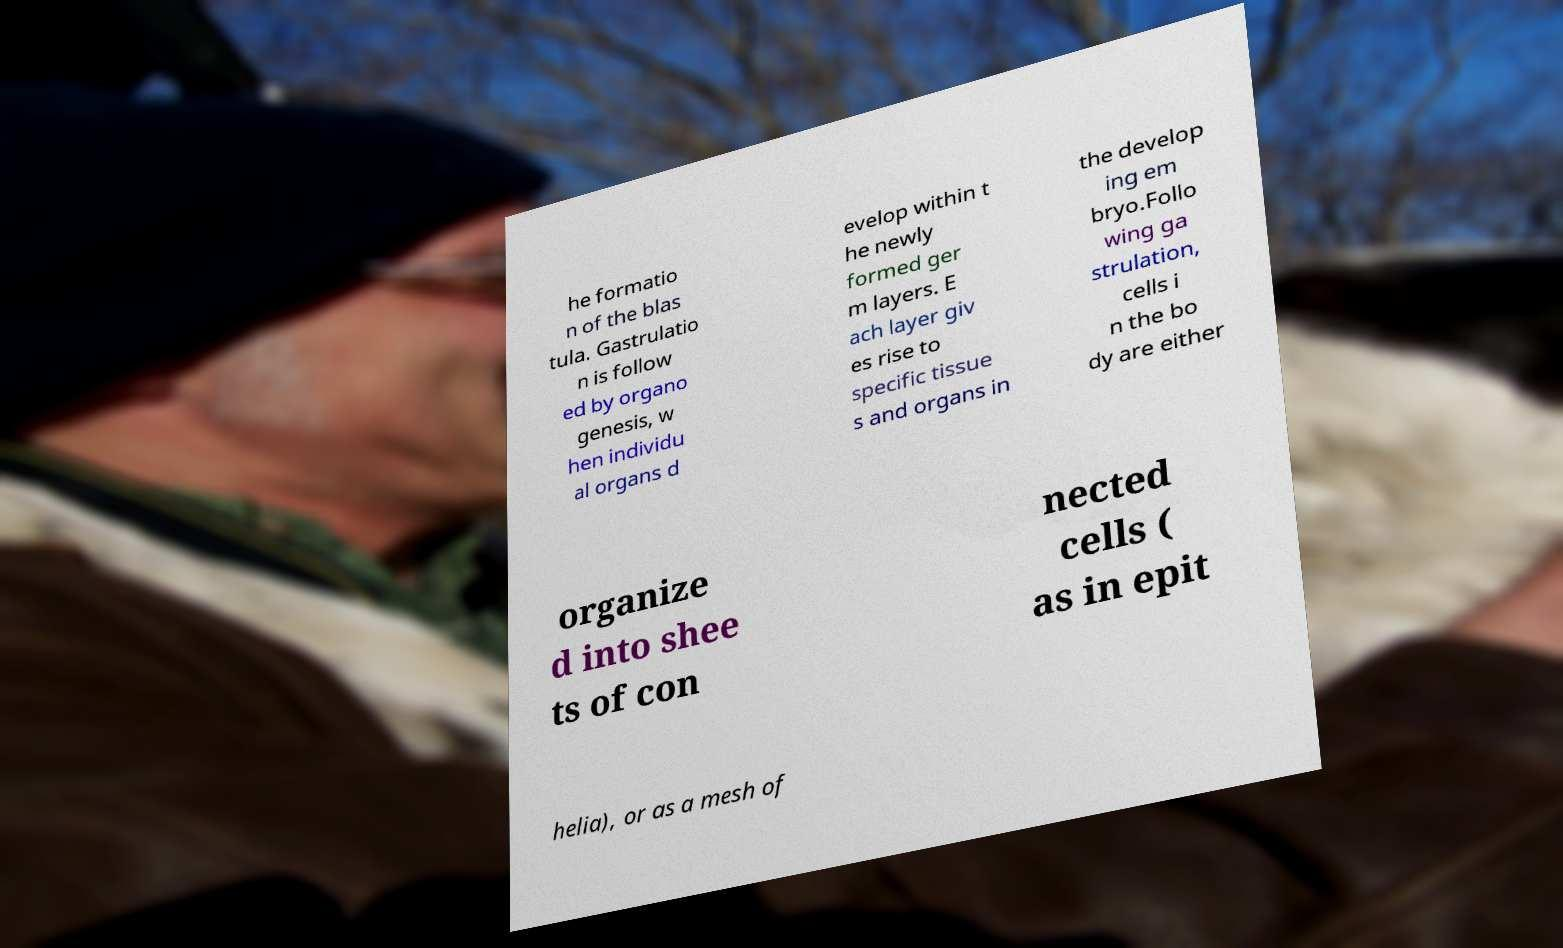Can you accurately transcribe the text from the provided image for me? he formatio n of the blas tula. Gastrulatio n is follow ed by organo genesis, w hen individu al organs d evelop within t he newly formed ger m layers. E ach layer giv es rise to specific tissue s and organs in the develop ing em bryo.Follo wing ga strulation, cells i n the bo dy are either organize d into shee ts of con nected cells ( as in epit helia), or as a mesh of 